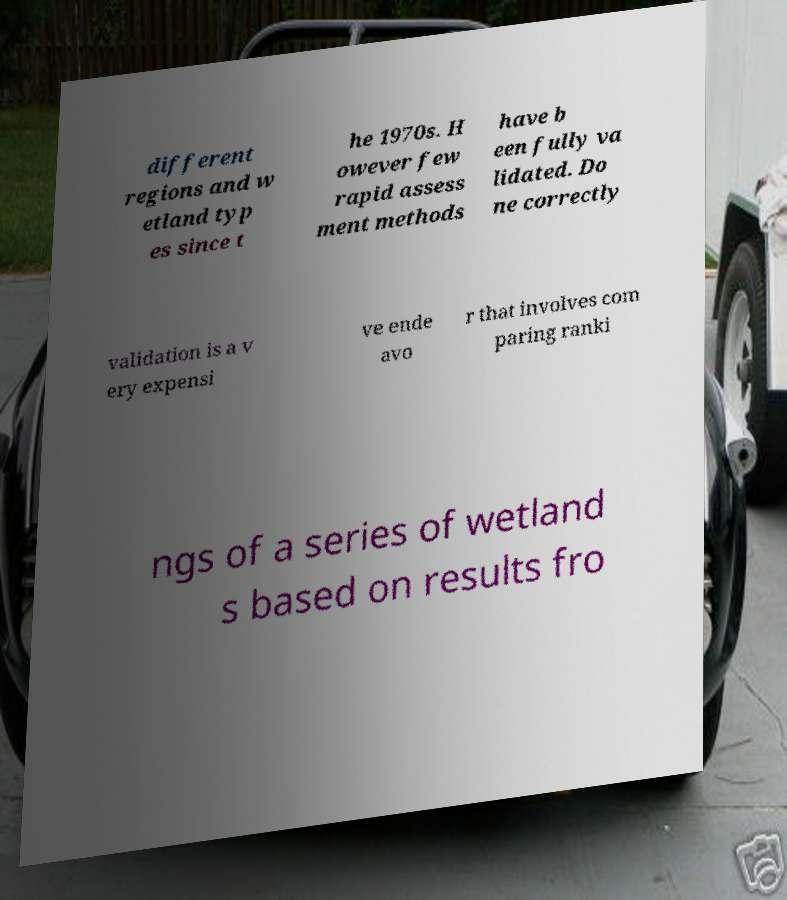There's text embedded in this image that I need extracted. Can you transcribe it verbatim? different regions and w etland typ es since t he 1970s. H owever few rapid assess ment methods have b een fully va lidated. Do ne correctly validation is a v ery expensi ve ende avo r that involves com paring ranki ngs of a series of wetland s based on results fro 